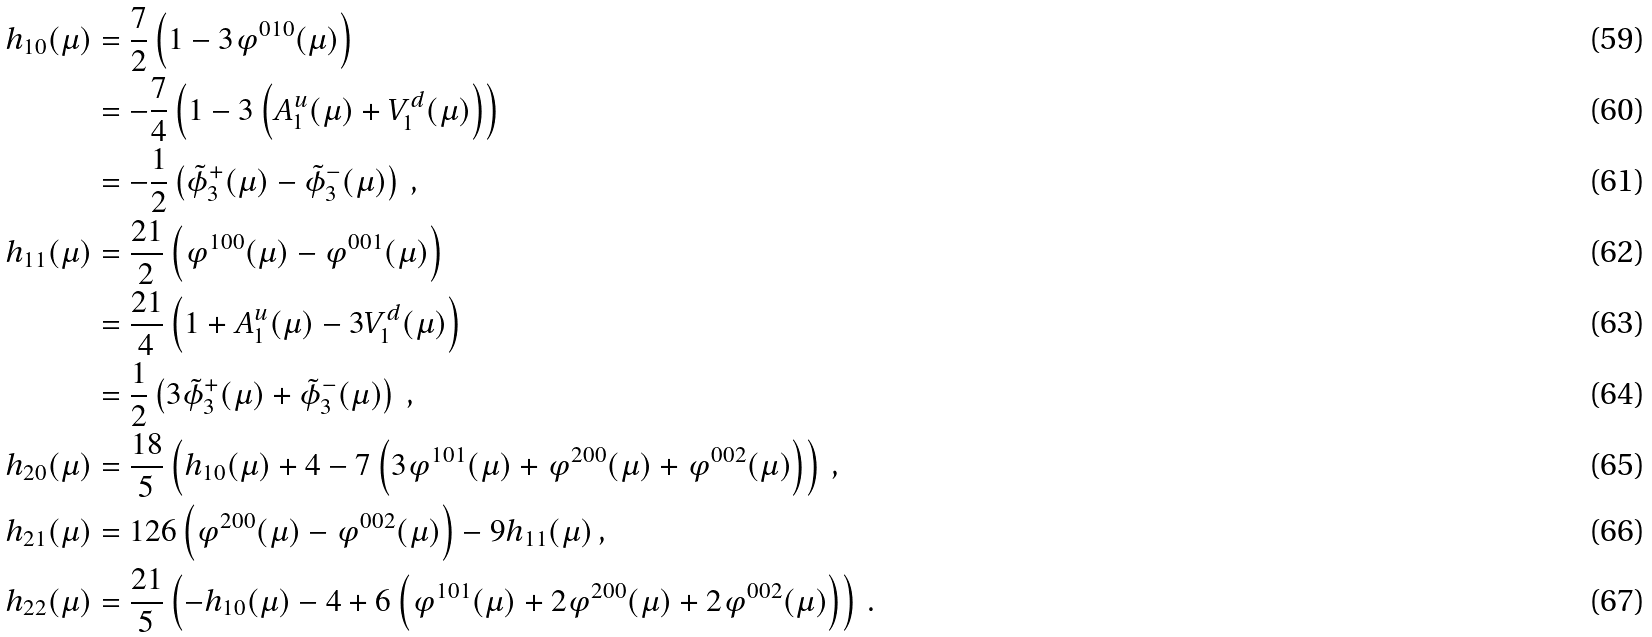<formula> <loc_0><loc_0><loc_500><loc_500>h _ { 1 0 } ( \mu ) & = \frac { 7 } { 2 } \left ( 1 - 3 \varphi ^ { 0 1 0 } ( \mu ) \right ) \\ & = - \frac { 7 } { 4 } \left ( 1 - 3 \left ( A _ { 1 } ^ { u } ( \mu ) + V _ { 1 } ^ { d } ( \mu ) \right ) \right ) \\ & = - \frac { 1 } { 2 } \left ( \tilde { \phi } _ { 3 } ^ { + } ( \mu ) - \tilde { \phi } _ { 3 } ^ { - } ( \mu ) \right ) \, , \\ h _ { 1 1 } ( \mu ) & = \frac { 2 1 } { 2 } \left ( \varphi ^ { 1 0 0 } ( \mu ) - \varphi ^ { 0 0 1 } ( \mu ) \right ) \\ & = \frac { 2 1 } { 4 } \left ( 1 + A _ { 1 } ^ { u } ( \mu ) - 3 V _ { 1 } ^ { d } ( \mu ) \right ) \\ & = \frac { 1 } { 2 } \left ( 3 \tilde { \phi } _ { 3 } ^ { + } ( \mu ) + \tilde { \phi } _ { 3 } ^ { - } ( \mu ) \right ) \, , \\ h _ { 2 0 } ( \mu ) & = \frac { 1 8 } { 5 } \left ( h _ { 1 0 } ( \mu ) + 4 - 7 \left ( 3 \varphi ^ { 1 0 1 } ( \mu ) + \varphi ^ { 2 0 0 } ( \mu ) + \varphi ^ { 0 0 2 } ( \mu ) \right ) \right ) \, , \\ h _ { 2 1 } ( \mu ) & = 1 2 6 \left ( \varphi ^ { 2 0 0 } ( \mu ) - \varphi ^ { 0 0 2 } ( \mu ) \right ) - 9 h _ { 1 1 } ( \mu ) \, , \\ h _ { 2 2 } ( \mu ) & = \frac { 2 1 } { 5 } \left ( - h _ { 1 0 } ( \mu ) - 4 + 6 \left ( \varphi ^ { 1 0 1 } ( \mu ) + 2 \varphi ^ { 2 0 0 } ( \mu ) + 2 \varphi ^ { 0 0 2 } ( \mu ) \right ) \right ) \, .</formula> 